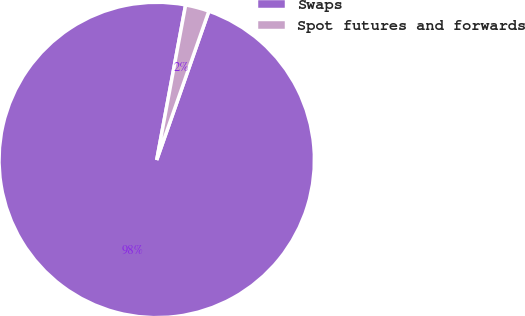Convert chart to OTSL. <chart><loc_0><loc_0><loc_500><loc_500><pie_chart><fcel>Swaps<fcel>Spot futures and forwards<nl><fcel>97.57%<fcel>2.43%<nl></chart> 